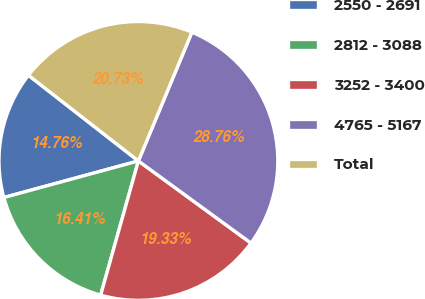Convert chart. <chart><loc_0><loc_0><loc_500><loc_500><pie_chart><fcel>2550 - 2691<fcel>2812 - 3088<fcel>3252 - 3400<fcel>4765 - 5167<fcel>Total<nl><fcel>14.76%<fcel>16.41%<fcel>19.33%<fcel>28.76%<fcel>20.73%<nl></chart> 